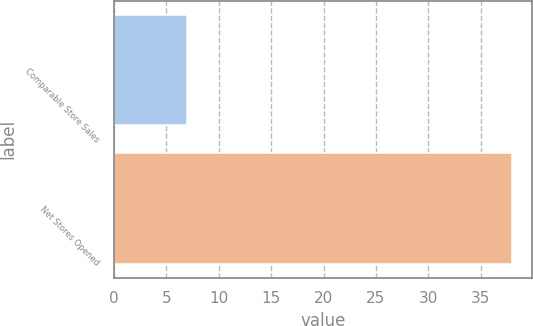Convert chart to OTSL. <chart><loc_0><loc_0><loc_500><loc_500><bar_chart><fcel>Comparable Store Sales<fcel>Net Stores Opened<nl><fcel>7<fcel>38<nl></chart> 